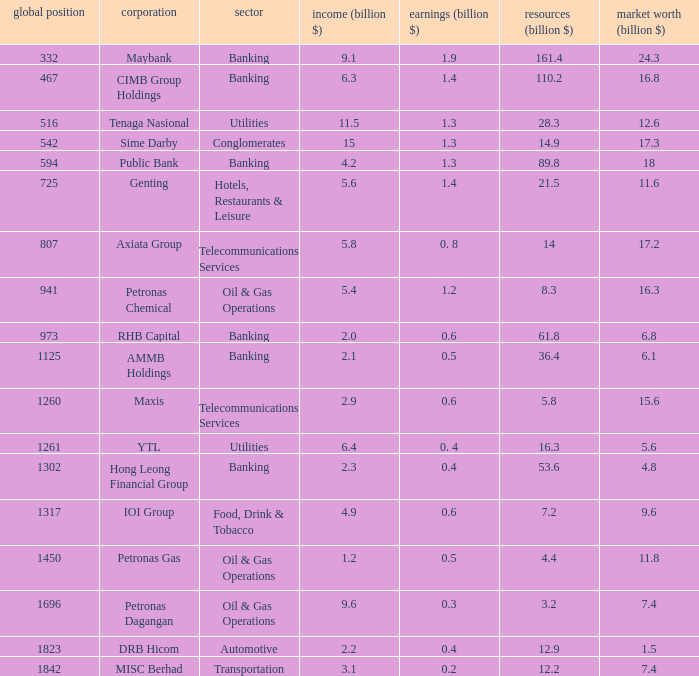Name the market value for rhb capital 6.8. 